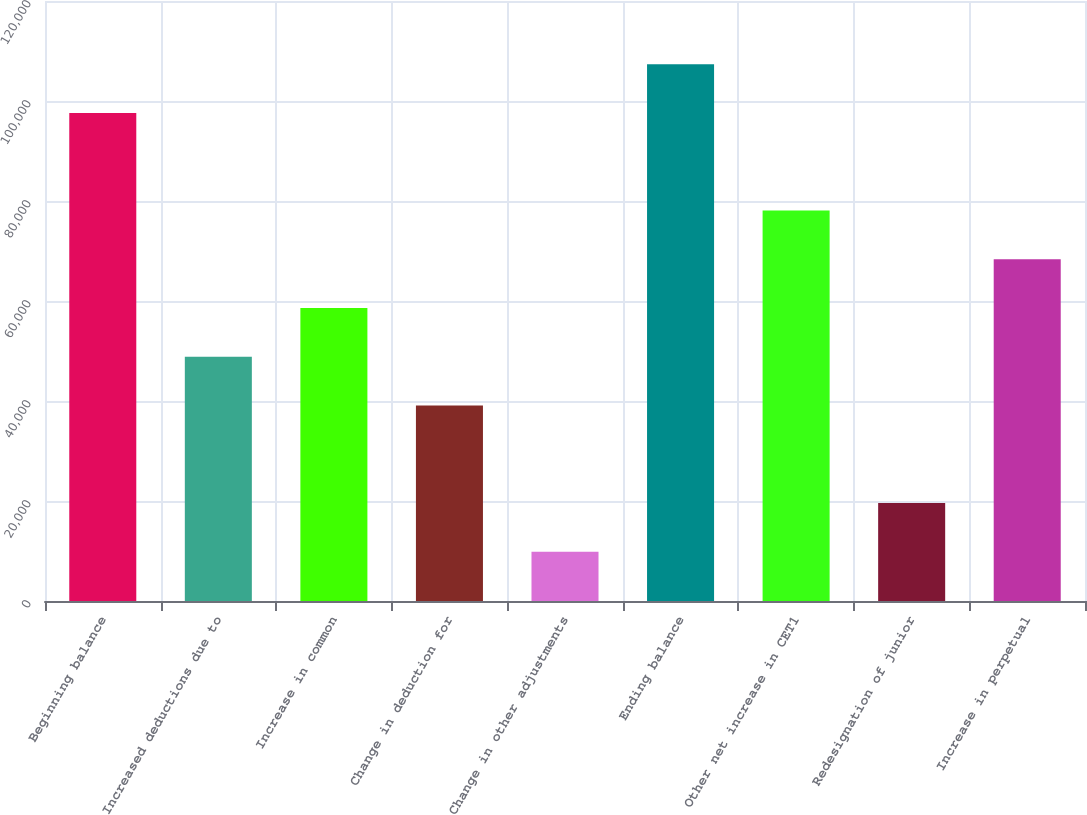Convert chart. <chart><loc_0><loc_0><loc_500><loc_500><bar_chart><fcel>Beginning balance<fcel>Increased deductions due to<fcel>Increase in common<fcel>Change in deduction for<fcel>Change in other adjustments<fcel>Ending balance<fcel>Other net increase in CET1<fcel>Redesignation of junior<fcel>Increase in perpetual<nl><fcel>97614<fcel>48844.5<fcel>58598.4<fcel>39090.6<fcel>9828.9<fcel>107368<fcel>78106.2<fcel>19582.8<fcel>68352.3<nl></chart> 